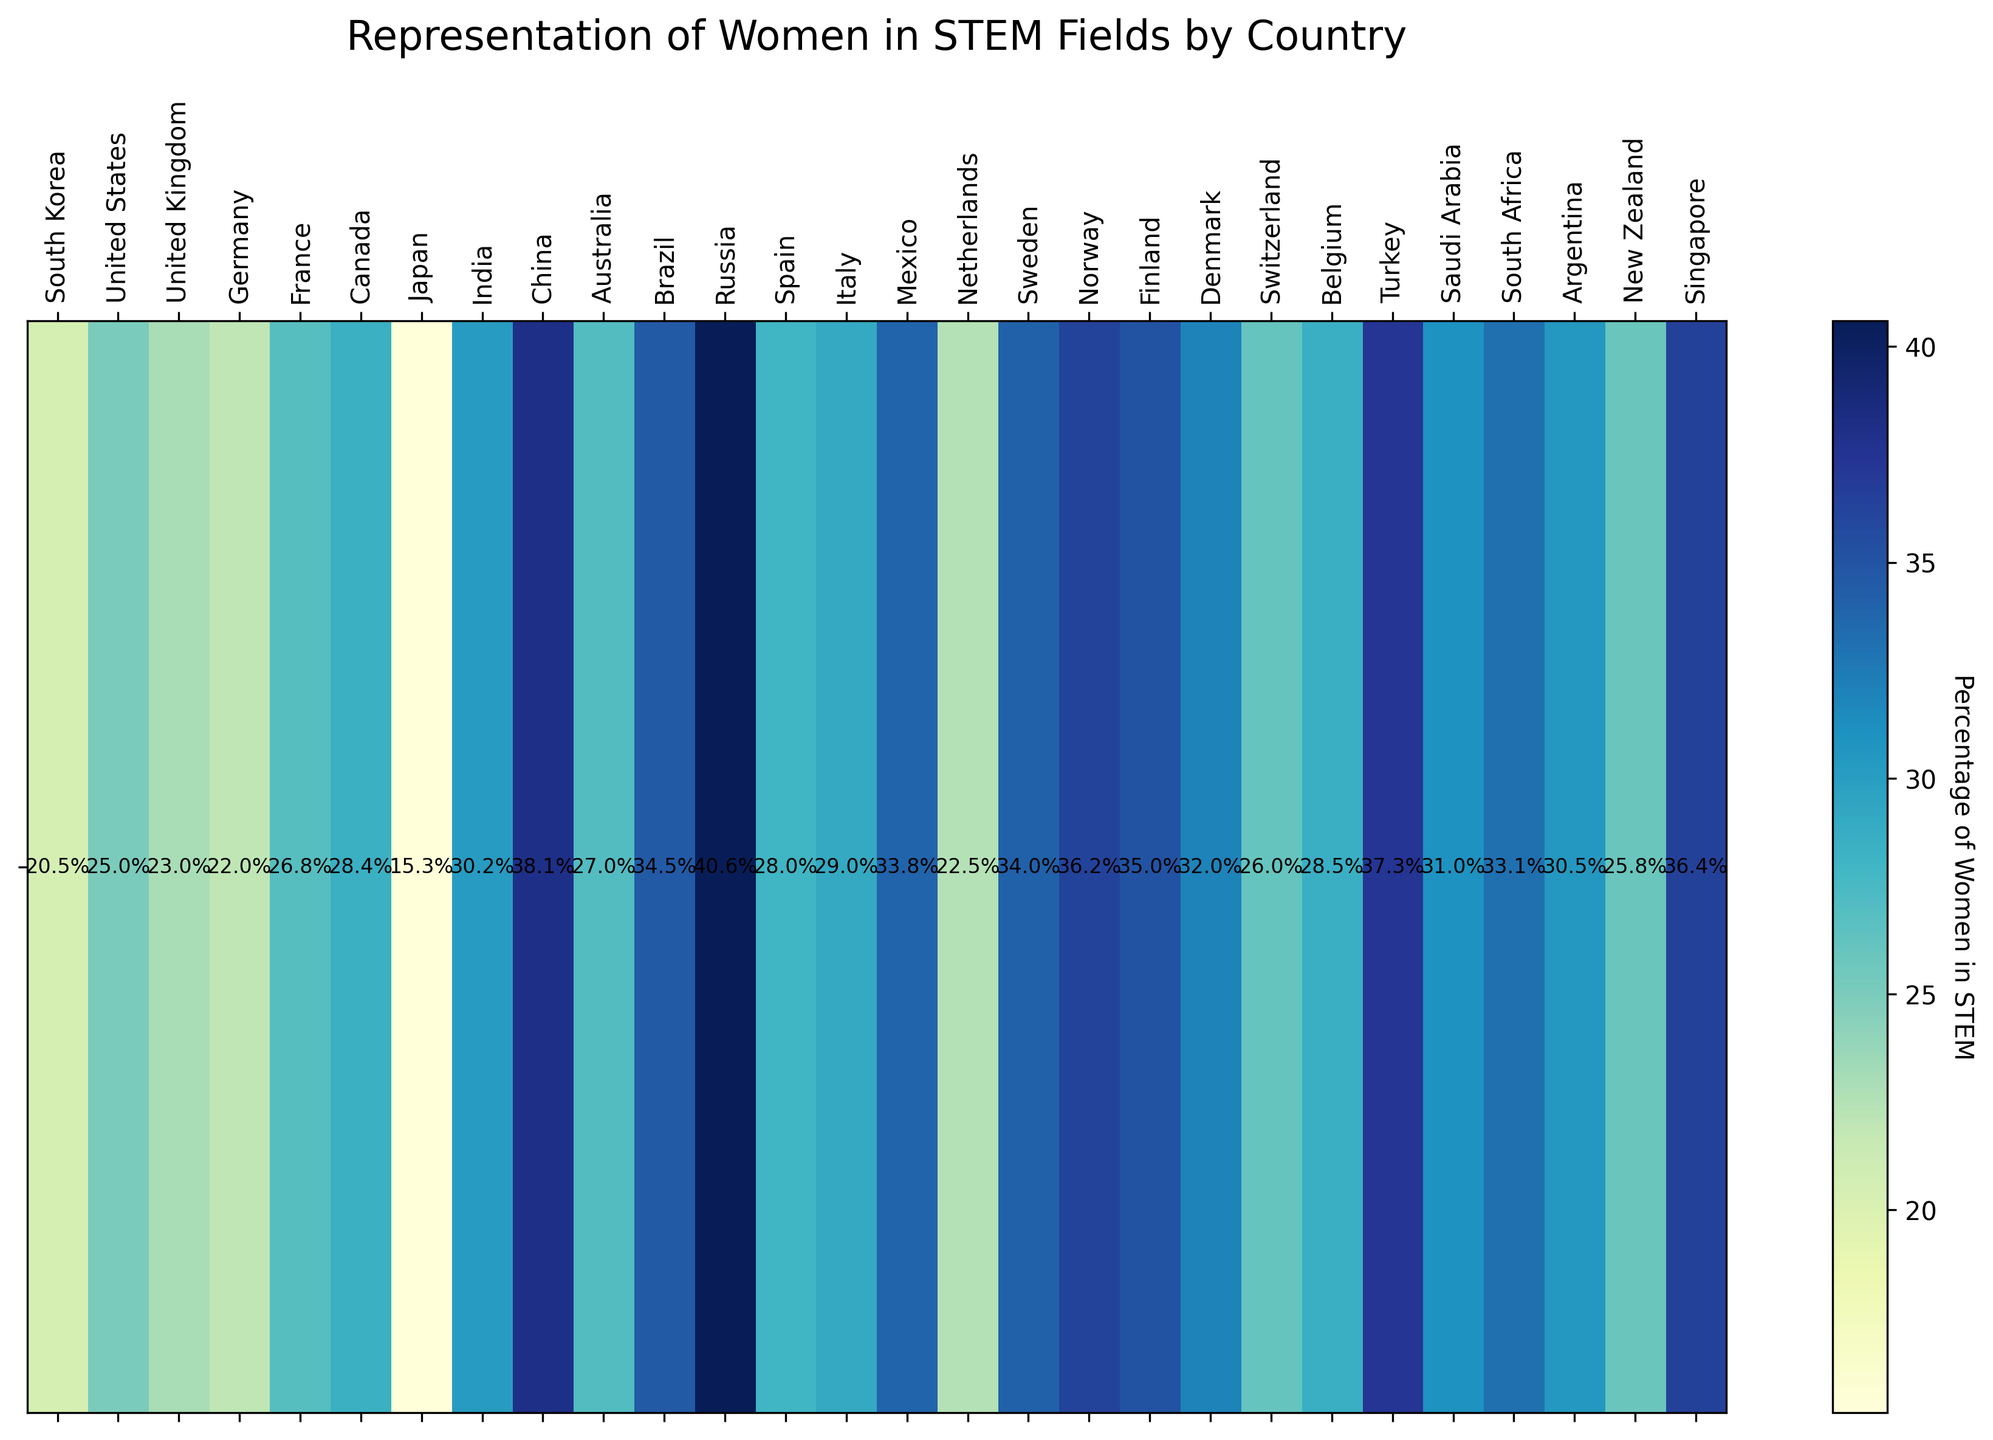Which country has the highest percentage of women in STEM? The heatmap shows the percentage of women in STEM for each country. Russia has the highest percentage at 40.6% according to the color intensity and the annotated percentage value.
Answer: Russia Which country has the lowest percentage of women in STEM? By examining the heatmap, Japan has the lowest percentage of women in STEM at 15.3% as indicated by the lightest color and the annotated percentage value.
Answer: Japan How many countries have a percentage of women in STEM above 30%? Observing the heatmap, the countries with a percentage above 30% are India, China, Brazil, Russia, Sweden, Norway, Denmark, Turkey, Saudi Arabia, South Africa, Argentina, and Singapore. This accounts for 12 countries.
Answer: 12 Which countries have a percentage of women in STEM between 25% and 30% inclusive? From the heatmap, the countries with percentages between 25% and 30% inclusive are United States (25.0), France (26.8), Australia (27.0), New Zealand (25.8), Switzerland (26.0), Belgium (28.5), and Italy (29.0).
Answer: United States, France, Australia, New Zealand, Switzerland, Belgium, Italy Compare the percentage of women in STEM in South Korea and Japan. Which country has a higher percentage and by how much? South Korea has 20.5% women in STEM, and Japan has 15.3%. So, South Korea has a higher percentage by 20.5 - 15.3 = 5.2%.
Answer: South Korea, 5.2% What is the average percentage of women in STEM across all listed countries? Adding all the percentage values and then dividing by the number of countries: (20.5 + 25.0 + 23.0 + 22.0 + 26.8 + 28.4 + 15.3 + 30.2 + 38.1 + 27.0 + 34.5 + 40.6 + 28.0 + 29.0 + 33.8 + 22.5 + 34.0 + 36.2 + 35.0 + 32.0 + 26.0 + 28.5 + 37.3 + 31.0 + 33.1 + 30.5 + 25.8 + 36.4) / 28 = 30.036%.
Answer: 30.0% Identify the country with the median percentage of women in STEM. Arranging the percentages in ascending order and finding the middle value(s): (15.3, 20.5, 22.0, 22.5, 23.0, 25.0, 25.8, 26.0, 26.8, 27.0, 28.0, 28.4, 28.5, 29.0, 30.2, 30.5, 31.0, 32.0, 33.1, 33.8, 34.0, 34.5, 35.0, 36.2, 36.4, 37.3, 38.1, 40.6). The middle values are 28.25, 28.5. Hence, it is Belgium.
Answer: Belgium Compare the visual color intensity for Germany and France. Which country's percentage of women in STEM is higher and what is the difference? Germany’s percentage is 22.0%, and France's is 26.8%. Thus, France's percentage is higher by 26.8 - 22.0 = 4.8%. The color for France is relatively darker which correlates with a higher percentage.
Answer: France, 4.8% Which countries have a percentage of women in STEM exactly equal to 28.0%? Observing the heatmap, Spain and Belgium have annotated percentages of 28.0%.
Answer: Spain, Belgium 